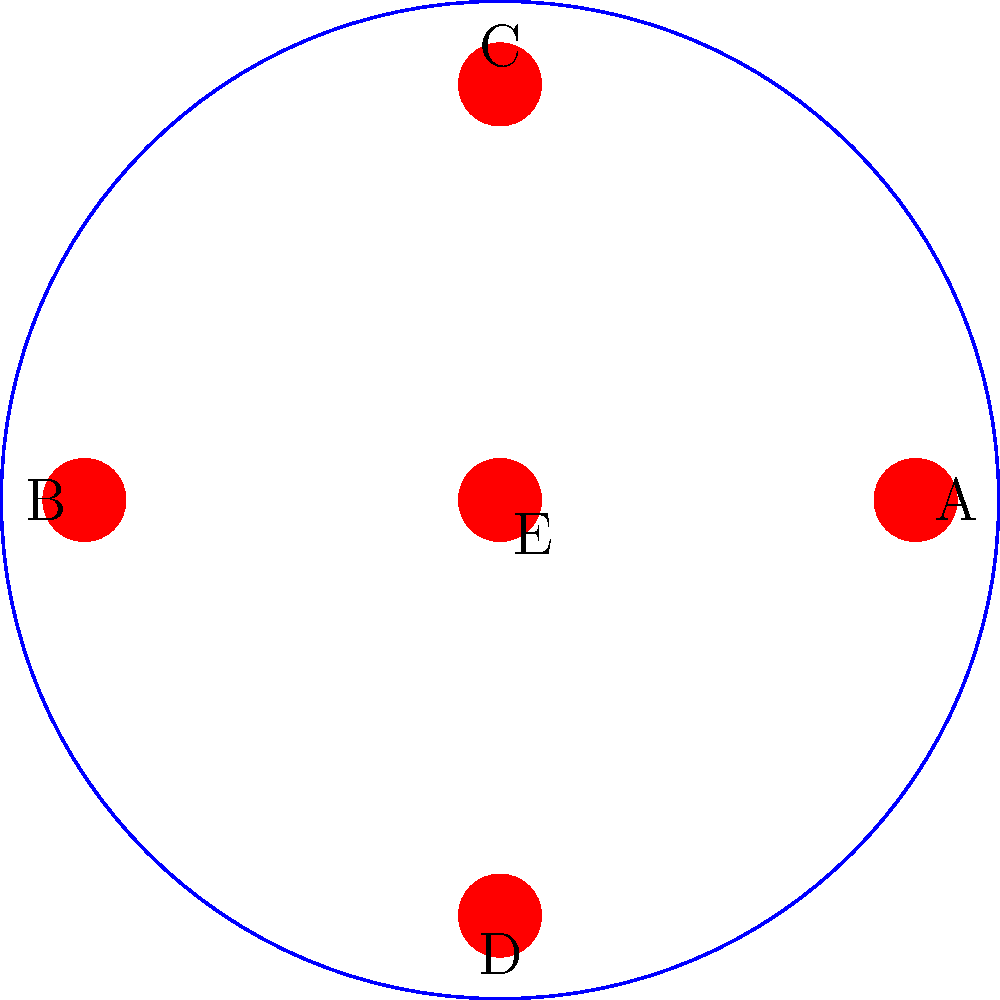In a historical depiction of a Portuguese naval formation, five ships are arranged symmetrically as shown in the diagram. Which symmetry operations would leave this formation unchanged? To determine the symmetry operations that leave the formation unchanged, we need to analyze the given arrangement:

1. Rotational symmetry:
   - The formation remains unchanged when rotated by 90°, 180°, 270°, and 360° around the center ship (E).
   - This indicates a 4-fold rotational symmetry (C4).

2. Reflection symmetry:
   - There are four lines of reflection:
     a) Vertical line through C, E, and D
     b) Horizontal line through A, E, and B
     c) Diagonal line through C, E, and A
     d) Diagonal line through B, E, and D

3. Identity:
   - The formation remains unchanged when no operation is applied (identity operation).

These symmetry operations form the dihedral group D4, which includes:
- 4 rotations (0°, 90°, 180°, 270°)
- 4 reflections (vertical, horizontal, and two diagonals)
- 1 identity operation

In total, there are 9 symmetry operations that leave the formation unchanged.
Answer: D4 group (9 symmetry operations) 